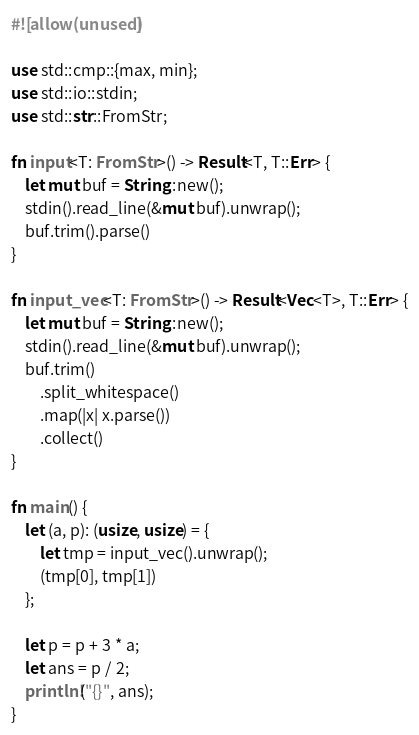<code> <loc_0><loc_0><loc_500><loc_500><_Rust_>#![allow(unused)]

use std::cmp::{max, min};
use std::io::stdin;
use std::str::FromStr;

fn input<T: FromStr>() -> Result<T, T::Err> {
    let mut buf = String::new();
    stdin().read_line(&mut buf).unwrap();
    buf.trim().parse()
}

fn input_vec<T: FromStr>() -> Result<Vec<T>, T::Err> {
    let mut buf = String::new();
    stdin().read_line(&mut buf).unwrap();
    buf.trim()
        .split_whitespace()
        .map(|x| x.parse())
        .collect()
}

fn main() {
    let (a, p): (usize, usize) = {
        let tmp = input_vec().unwrap();
        (tmp[0], tmp[1])
    };

    let p = p + 3 * a;
    let ans = p / 2;
    println!("{}", ans);
}
</code> 